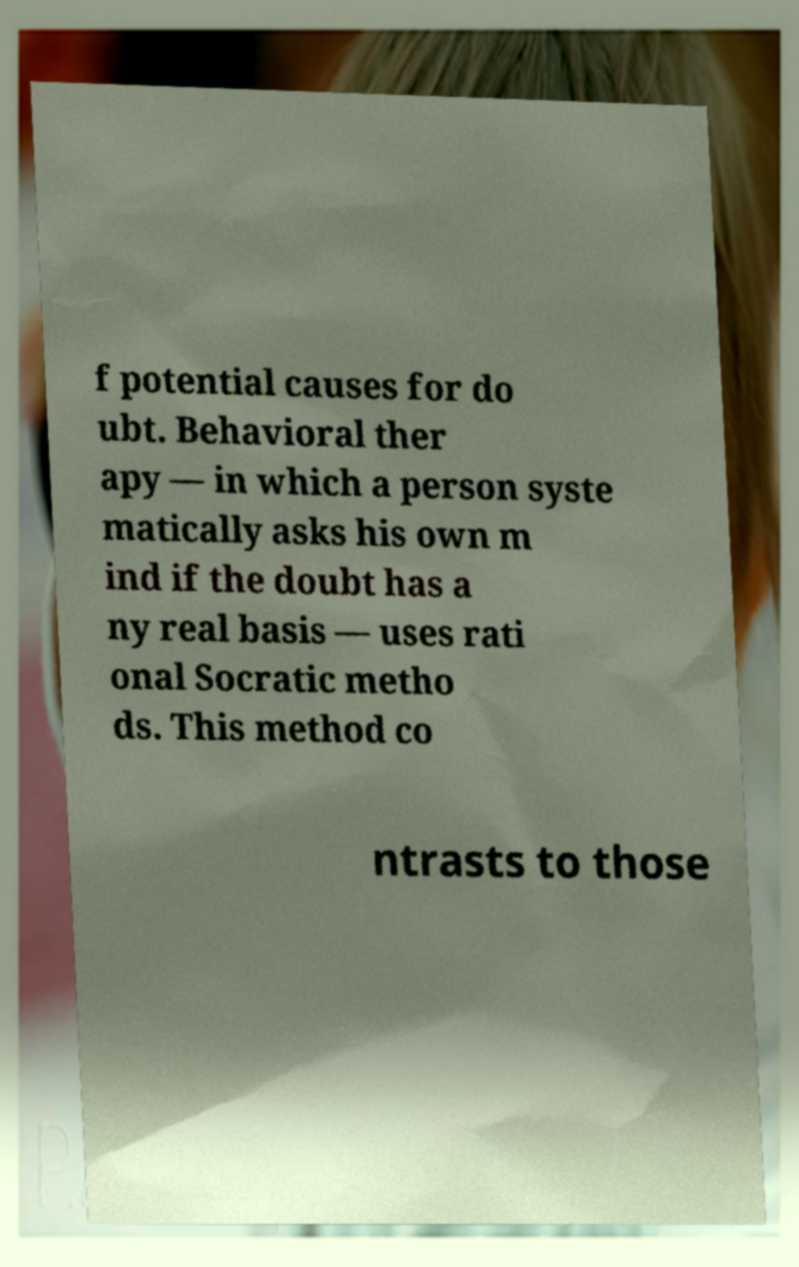Please identify and transcribe the text found in this image. f potential causes for do ubt. Behavioral ther apy — in which a person syste matically asks his own m ind if the doubt has a ny real basis — uses rati onal Socratic metho ds. This method co ntrasts to those 